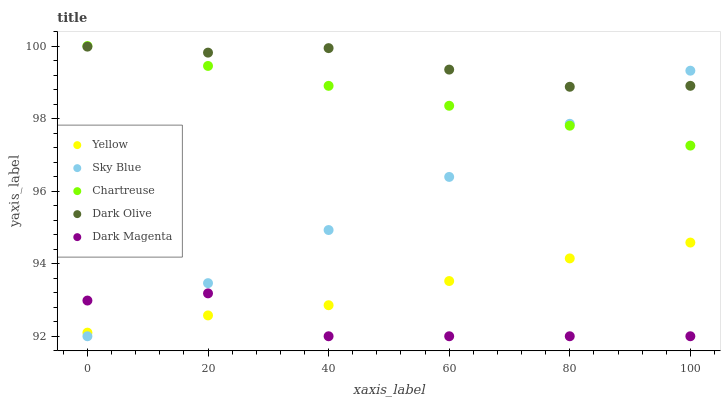Does Dark Magenta have the minimum area under the curve?
Answer yes or no. Yes. Does Dark Olive have the maximum area under the curve?
Answer yes or no. Yes. Does Chartreuse have the minimum area under the curve?
Answer yes or no. No. Does Chartreuse have the maximum area under the curve?
Answer yes or no. No. Is Sky Blue the smoothest?
Answer yes or no. Yes. Is Dark Magenta the roughest?
Answer yes or no. Yes. Is Chartreuse the smoothest?
Answer yes or no. No. Is Chartreuse the roughest?
Answer yes or no. No. Does Sky Blue have the lowest value?
Answer yes or no. Yes. Does Chartreuse have the lowest value?
Answer yes or no. No. Does Chartreuse have the highest value?
Answer yes or no. Yes. Does Dark Olive have the highest value?
Answer yes or no. No. Is Dark Magenta less than Chartreuse?
Answer yes or no. Yes. Is Dark Olive greater than Yellow?
Answer yes or no. Yes. Does Yellow intersect Dark Magenta?
Answer yes or no. Yes. Is Yellow less than Dark Magenta?
Answer yes or no. No. Is Yellow greater than Dark Magenta?
Answer yes or no. No. Does Dark Magenta intersect Chartreuse?
Answer yes or no. No. 